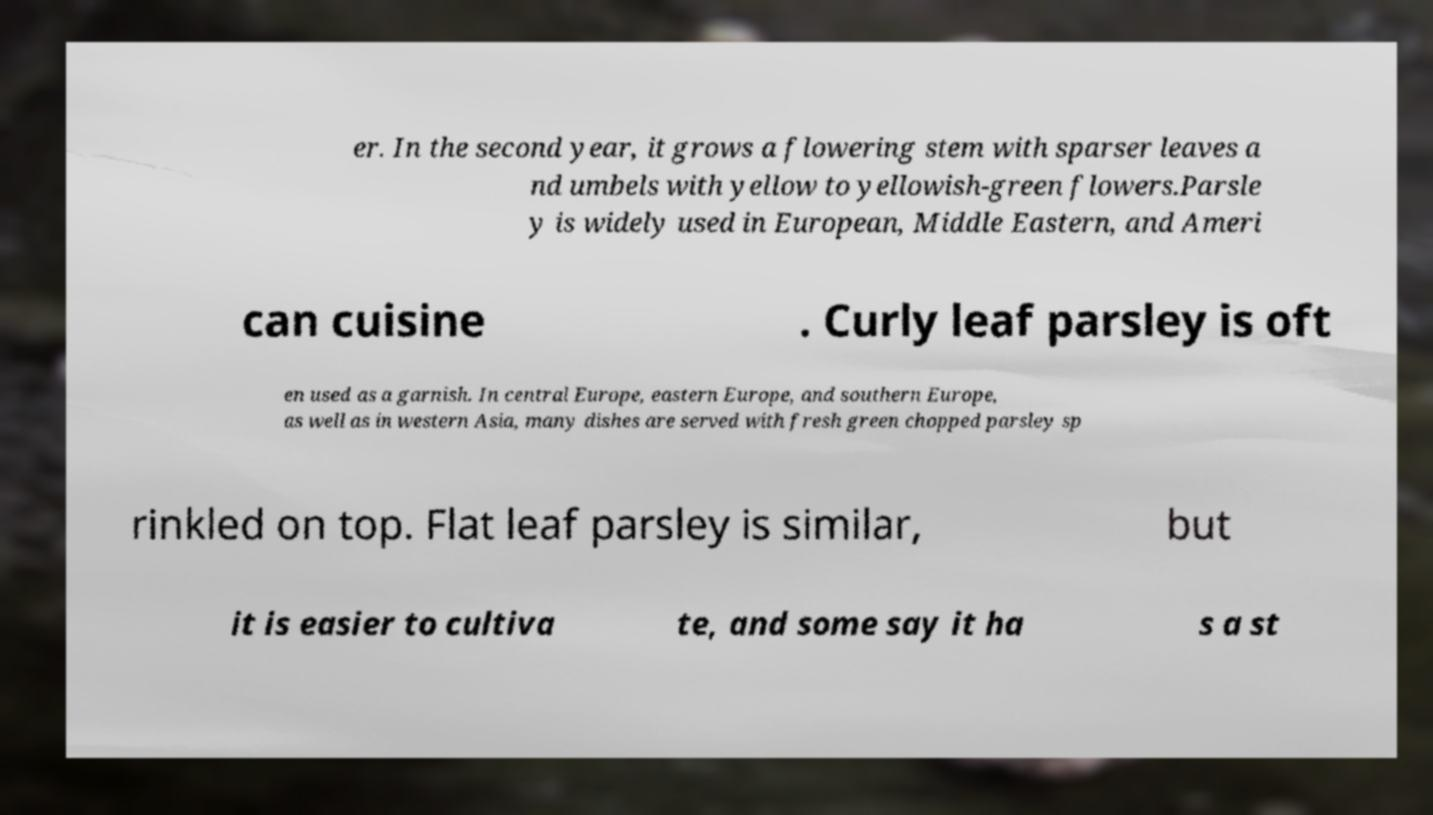There's text embedded in this image that I need extracted. Can you transcribe it verbatim? er. In the second year, it grows a flowering stem with sparser leaves a nd umbels with yellow to yellowish-green flowers.Parsle y is widely used in European, Middle Eastern, and Ameri can cuisine . Curly leaf parsley is oft en used as a garnish. In central Europe, eastern Europe, and southern Europe, as well as in western Asia, many dishes are served with fresh green chopped parsley sp rinkled on top. Flat leaf parsley is similar, but it is easier to cultiva te, and some say it ha s a st 